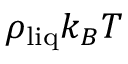<formula> <loc_0><loc_0><loc_500><loc_500>\rho _ { l i q } k _ { B } T</formula> 